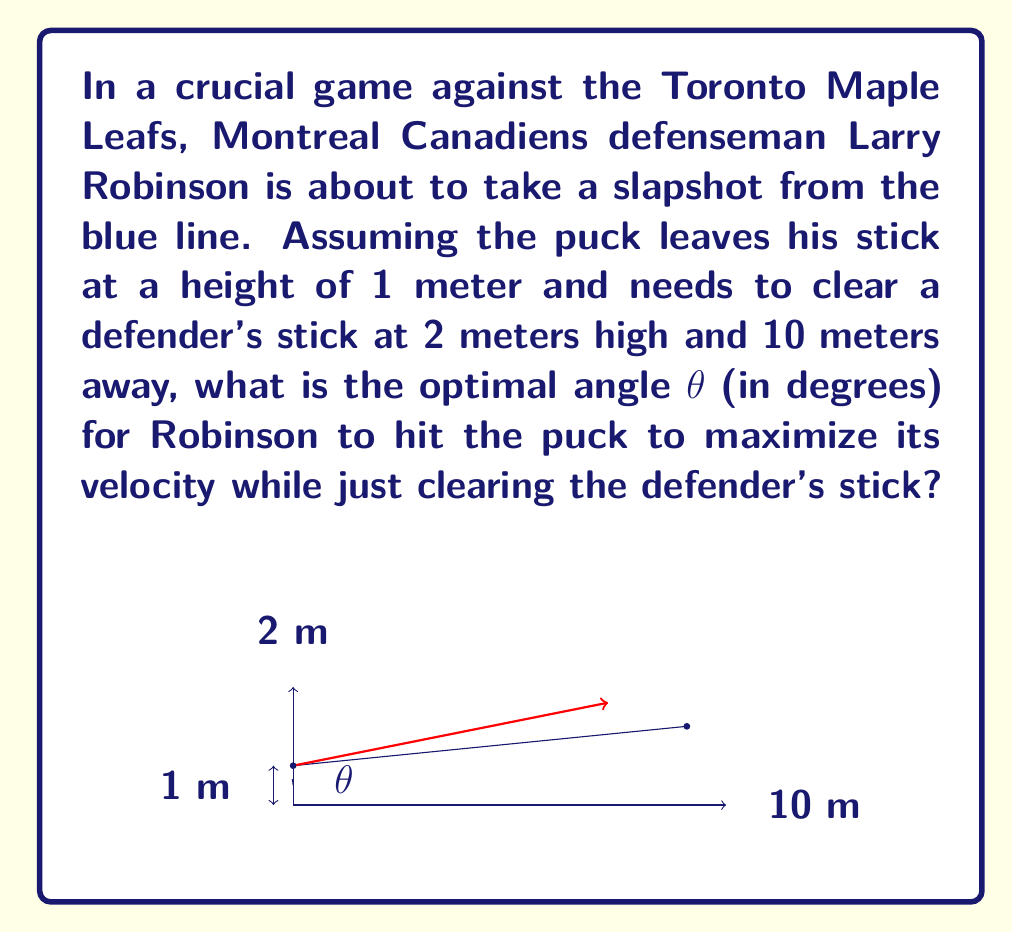Teach me how to tackle this problem. To solve this problem, we'll follow these steps:

1) First, we need to understand that the optimal angle for maximum velocity is the smallest angle that allows the puck to clear the defender's stick.

2) We can model this situation as a right triangle, where:
   - The base of the triangle is the distance to the defender (10 m)
   - The height of the triangle is the difference in heights (2 m - 1 m = 1 m)

3) We can use the arctangent function to find this angle:

   $$θ = \arctan(\frac{\text{opposite}}{\text{adjacent}})$$

4) Plugging in our values:

   $$θ = \arctan(\frac{1}{10})$$

5) Calculate this value:

   $$θ = \arctan(0.1) \approx 0.0997 \text{ radians}$$

6) Convert radians to degrees:

   $$θ \approx 0.0997 \times \frac{180°}{\pi} \approx 5.71°$$

7) Round to the nearest tenth of a degree:

   $$θ \approx 5.7°$$

This angle will allow the puck to just clear the defender's stick while maximizing its velocity.
Answer: 5.7° 